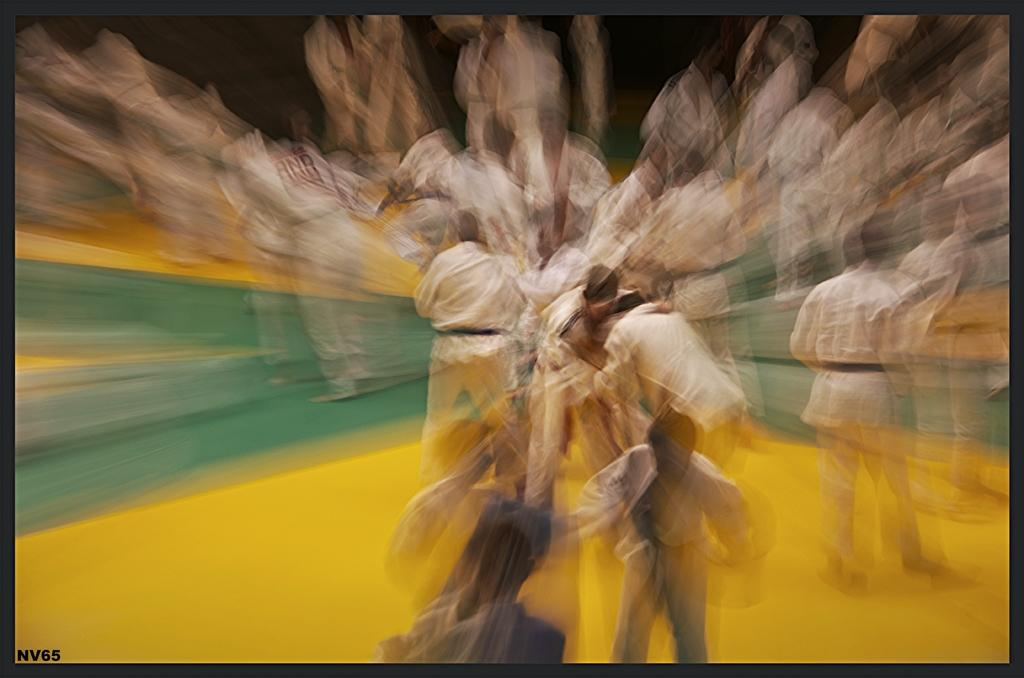How many people are in the image? There are persons in the image, but the exact number is not specified. What are the persons wearing in the image? The persons are wearing clothes in the image. What type of plants can be seen growing on the trail in the image? There is no trail or plants present in the image. 